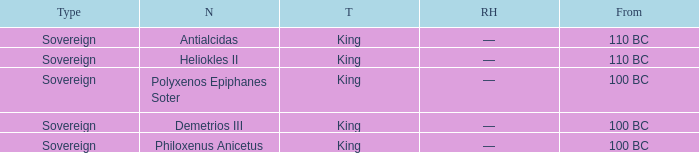Can you give me this table as a dict? {'header': ['Type', 'N', 'T', 'RH', 'From'], 'rows': [['Sovereign', 'Antialcidas', 'King', '—', '110 BC'], ['Sovereign', 'Heliokles II', 'King', '—', '110 BC'], ['Sovereign', 'Polyxenos Epiphanes Soter', 'King', '—', '100 BC'], ['Sovereign', 'Demetrios III', 'King', '—', '100 BC'], ['Sovereign', 'Philoxenus Anicetus', 'King', '—', '100 BC']]} When did Demetrios III begin to hold power? 100 BC. 